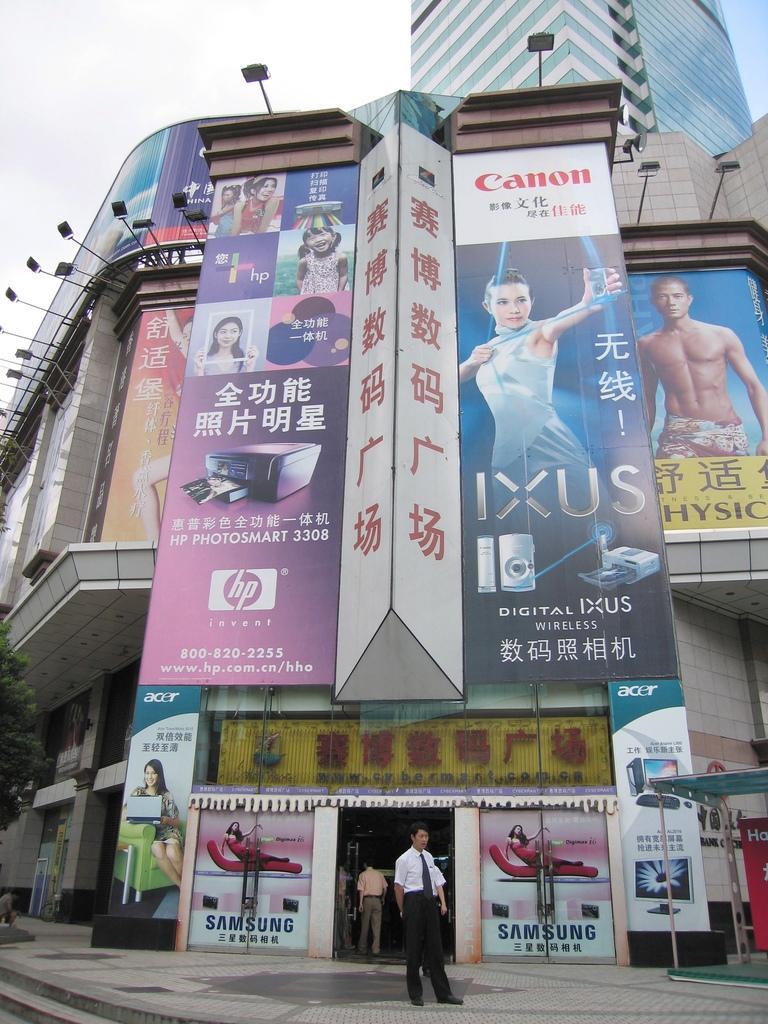Describe this image in one or two sentences. In this there is a building in the center of the image, on which there are posters and there are shops and men at the bottom side of the image and there is another building at the top side of the image. 